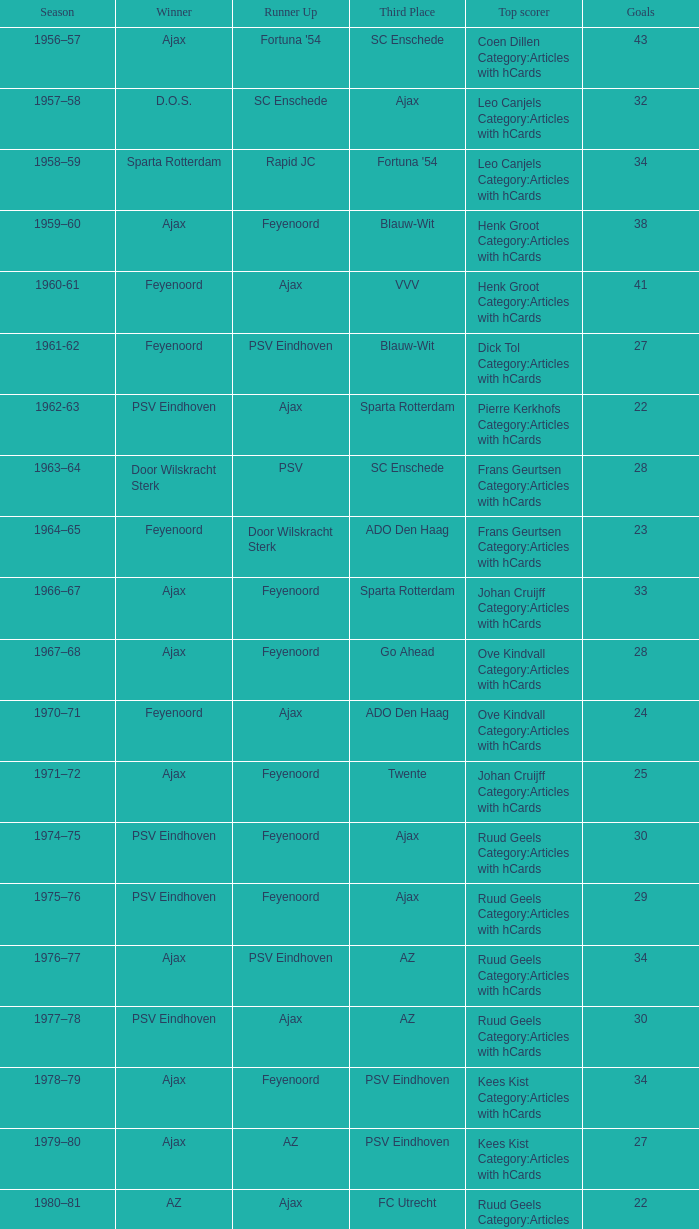When twente ranked third and ajax triumphed, what were the seasons? 1971–72, 1989-90. 